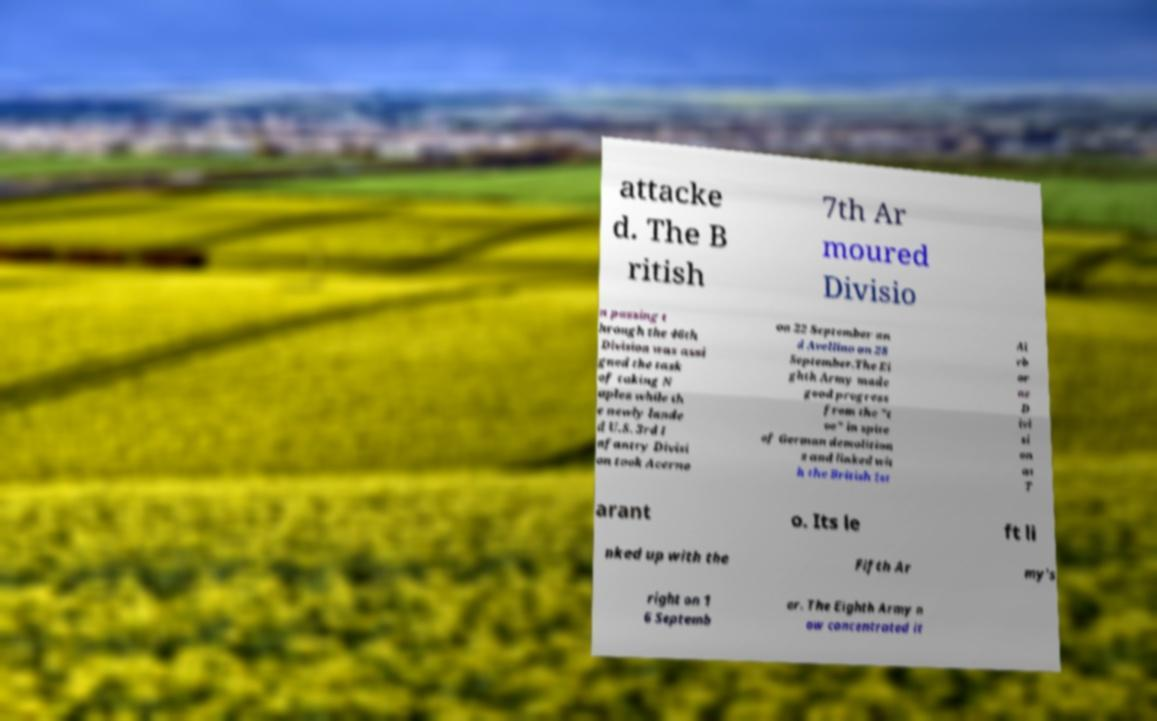Could you assist in decoding the text presented in this image and type it out clearly? attacke d. The B ritish 7th Ar moured Divisio n passing t hrough the 46th Division was assi gned the task of taking N aples while th e newly lande d U.S. 3rd I nfantry Divisi on took Acerno on 22 September an d Avellino on 28 September.The Ei ghth Army made good progress from the "t oe" in spite of German demolition s and linked wit h the British 1st Ai rb or ne D ivi si on at T arant o. Its le ft li nked up with the Fifth Ar my's right on 1 6 Septemb er. The Eighth Army n ow concentrated it 